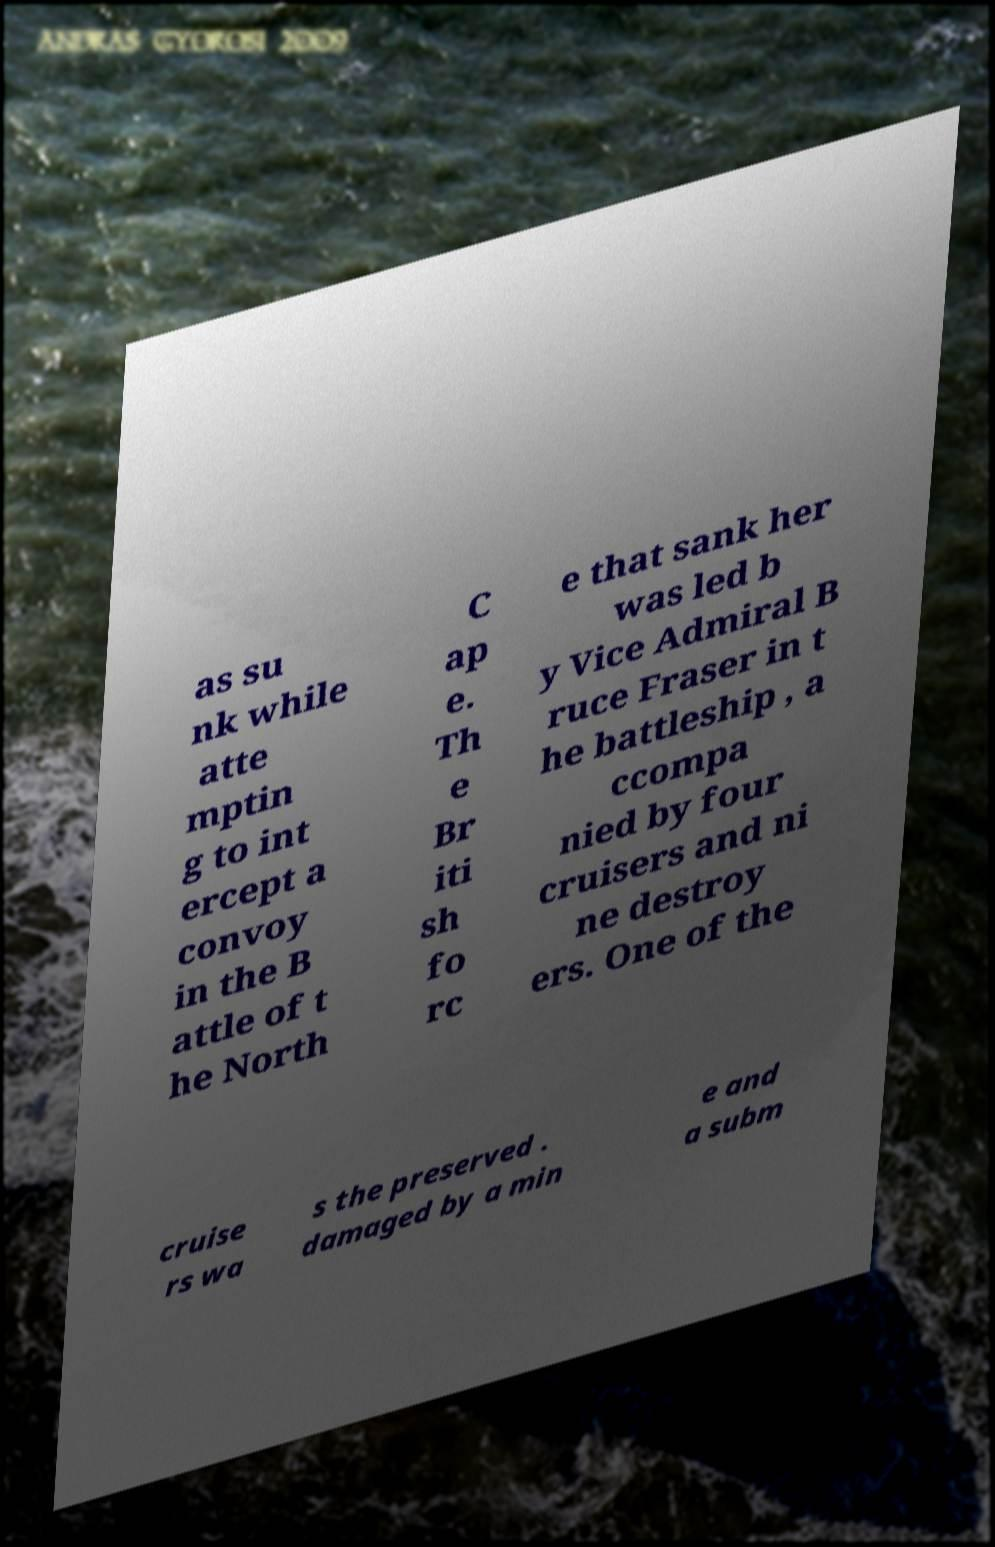Can you read and provide the text displayed in the image?This photo seems to have some interesting text. Can you extract and type it out for me? as su nk while atte mptin g to int ercept a convoy in the B attle of t he North C ap e. Th e Br iti sh fo rc e that sank her was led b y Vice Admiral B ruce Fraser in t he battleship , a ccompa nied by four cruisers and ni ne destroy ers. One of the cruise rs wa s the preserved . damaged by a min e and a subm 